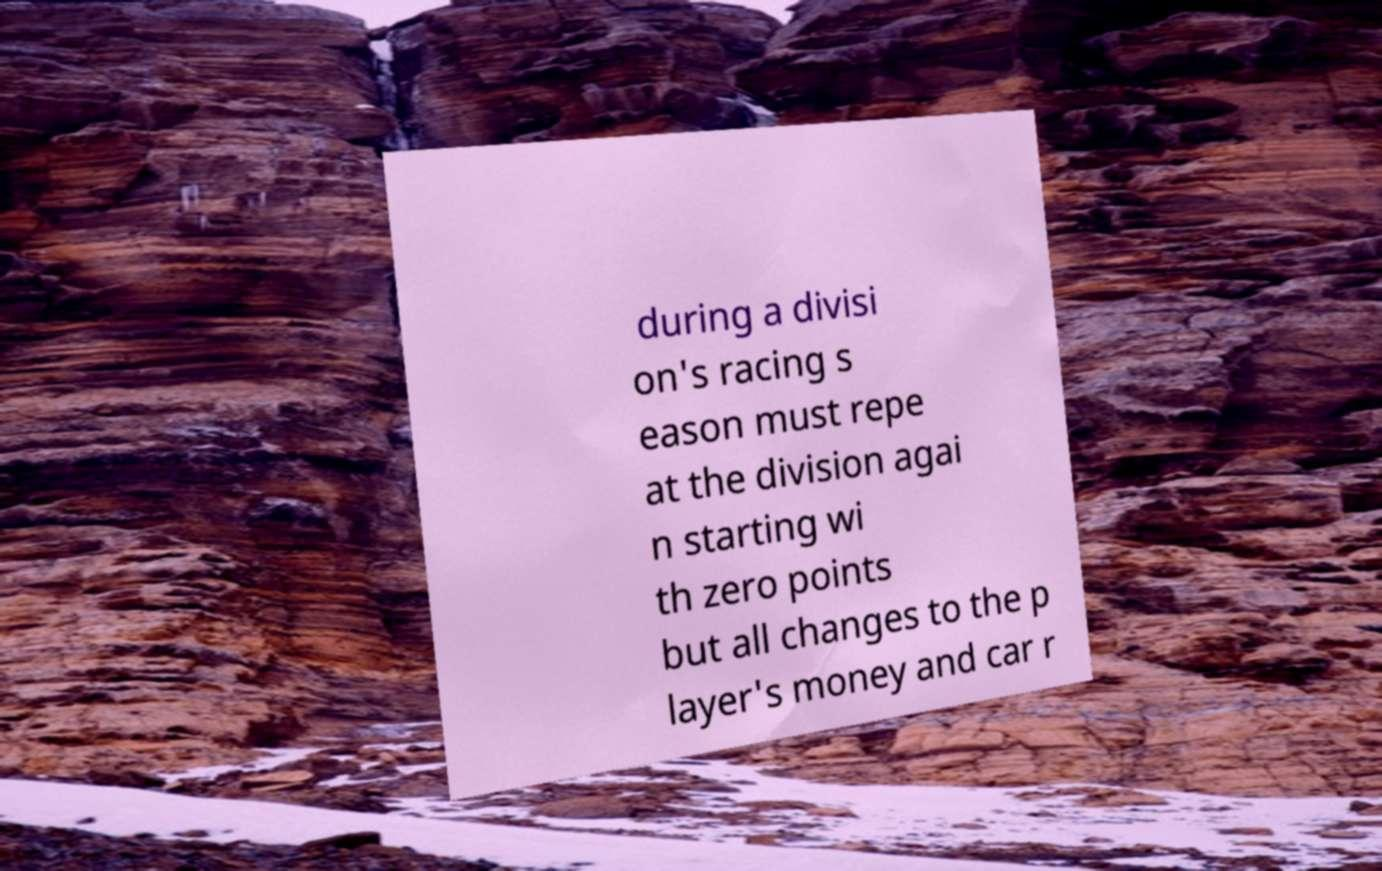Could you extract and type out the text from this image? during a divisi on's racing s eason must repe at the division agai n starting wi th zero points but all changes to the p layer's money and car r 